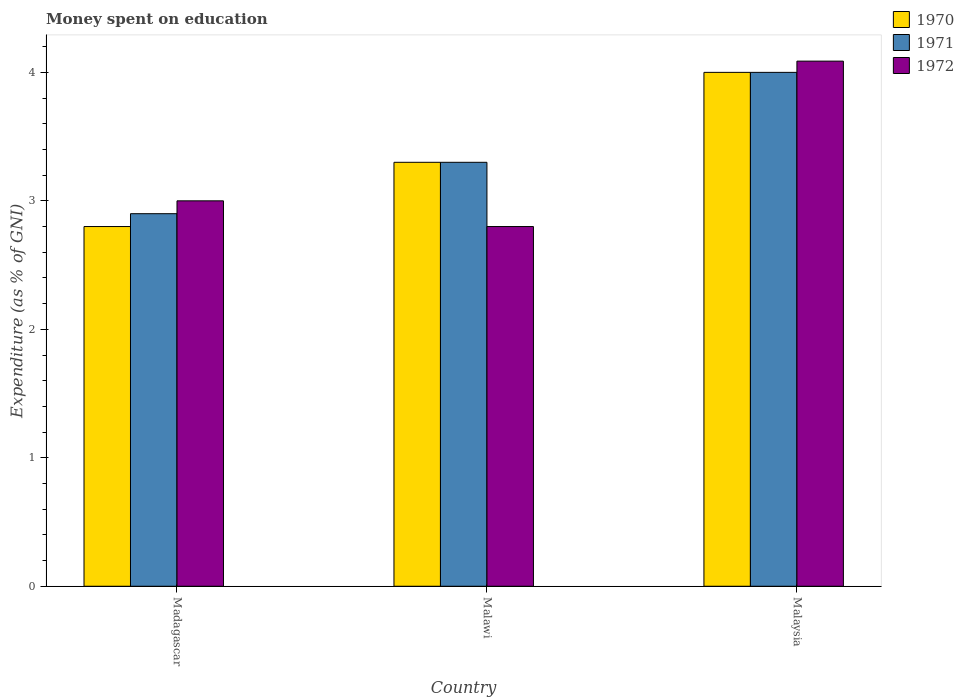How many different coloured bars are there?
Keep it short and to the point. 3. Are the number of bars per tick equal to the number of legend labels?
Offer a very short reply. Yes. How many bars are there on the 2nd tick from the left?
Ensure brevity in your answer.  3. What is the label of the 3rd group of bars from the left?
Provide a succinct answer. Malaysia. What is the amount of money spent on education in 1970 in Malaysia?
Provide a succinct answer. 4. Across all countries, what is the maximum amount of money spent on education in 1970?
Your answer should be compact. 4. In which country was the amount of money spent on education in 1972 maximum?
Your answer should be very brief. Malaysia. In which country was the amount of money spent on education in 1971 minimum?
Give a very brief answer. Madagascar. What is the total amount of money spent on education in 1971 in the graph?
Offer a terse response. 10.2. What is the difference between the amount of money spent on education in 1972 in Malawi and that in Malaysia?
Your answer should be very brief. -1.29. What is the difference between the amount of money spent on education in 1970 in Malawi and the amount of money spent on education in 1971 in Madagascar?
Provide a short and direct response. 0.4. What is the difference between the amount of money spent on education of/in 1972 and amount of money spent on education of/in 1971 in Madagascar?
Provide a short and direct response. 0.1. What is the ratio of the amount of money spent on education in 1971 in Malawi to that in Malaysia?
Give a very brief answer. 0.82. Is the amount of money spent on education in 1972 in Madagascar less than that in Malawi?
Your response must be concise. No. What is the difference between the highest and the second highest amount of money spent on education in 1972?
Ensure brevity in your answer.  -0.2. What is the difference between the highest and the lowest amount of money spent on education in 1970?
Your answer should be compact. 1.2. Is the sum of the amount of money spent on education in 1971 in Malawi and Malaysia greater than the maximum amount of money spent on education in 1970 across all countries?
Keep it short and to the point. Yes. What does the 1st bar from the left in Malawi represents?
Provide a short and direct response. 1970. What does the 2nd bar from the right in Madagascar represents?
Your answer should be very brief. 1971. Is it the case that in every country, the sum of the amount of money spent on education in 1971 and amount of money spent on education in 1972 is greater than the amount of money spent on education in 1970?
Provide a short and direct response. Yes. How many bars are there?
Provide a short and direct response. 9. How many countries are there in the graph?
Give a very brief answer. 3. Does the graph contain any zero values?
Your response must be concise. No. What is the title of the graph?
Your answer should be very brief. Money spent on education. Does "1975" appear as one of the legend labels in the graph?
Make the answer very short. No. What is the label or title of the Y-axis?
Your answer should be compact. Expenditure (as % of GNI). What is the Expenditure (as % of GNI) of 1972 in Madagascar?
Provide a succinct answer. 3. What is the Expenditure (as % of GNI) in 1972 in Malawi?
Your answer should be compact. 2.8. What is the Expenditure (as % of GNI) in 1972 in Malaysia?
Your answer should be very brief. 4.09. Across all countries, what is the maximum Expenditure (as % of GNI) of 1972?
Keep it short and to the point. 4.09. What is the total Expenditure (as % of GNI) of 1970 in the graph?
Your answer should be compact. 10.1. What is the total Expenditure (as % of GNI) of 1972 in the graph?
Offer a very short reply. 9.89. What is the difference between the Expenditure (as % of GNI) of 1972 in Madagascar and that in Malawi?
Provide a short and direct response. 0.2. What is the difference between the Expenditure (as % of GNI) in 1970 in Madagascar and that in Malaysia?
Provide a succinct answer. -1.2. What is the difference between the Expenditure (as % of GNI) in 1971 in Madagascar and that in Malaysia?
Offer a terse response. -1.1. What is the difference between the Expenditure (as % of GNI) of 1972 in Madagascar and that in Malaysia?
Offer a terse response. -1.09. What is the difference between the Expenditure (as % of GNI) in 1972 in Malawi and that in Malaysia?
Give a very brief answer. -1.29. What is the difference between the Expenditure (as % of GNI) in 1970 in Madagascar and the Expenditure (as % of GNI) in 1971 in Malawi?
Give a very brief answer. -0.5. What is the difference between the Expenditure (as % of GNI) in 1970 in Madagascar and the Expenditure (as % of GNI) in 1972 in Malawi?
Your answer should be very brief. 0. What is the difference between the Expenditure (as % of GNI) of 1970 in Madagascar and the Expenditure (as % of GNI) of 1971 in Malaysia?
Provide a short and direct response. -1.2. What is the difference between the Expenditure (as % of GNI) of 1970 in Madagascar and the Expenditure (as % of GNI) of 1972 in Malaysia?
Your answer should be very brief. -1.29. What is the difference between the Expenditure (as % of GNI) of 1971 in Madagascar and the Expenditure (as % of GNI) of 1972 in Malaysia?
Make the answer very short. -1.19. What is the difference between the Expenditure (as % of GNI) of 1970 in Malawi and the Expenditure (as % of GNI) of 1972 in Malaysia?
Give a very brief answer. -0.79. What is the difference between the Expenditure (as % of GNI) in 1971 in Malawi and the Expenditure (as % of GNI) in 1972 in Malaysia?
Your answer should be very brief. -0.79. What is the average Expenditure (as % of GNI) in 1970 per country?
Your response must be concise. 3.37. What is the average Expenditure (as % of GNI) of 1972 per country?
Make the answer very short. 3.3. What is the difference between the Expenditure (as % of GNI) in 1970 and Expenditure (as % of GNI) in 1971 in Madagascar?
Your answer should be compact. -0.1. What is the difference between the Expenditure (as % of GNI) of 1970 and Expenditure (as % of GNI) of 1972 in Malawi?
Make the answer very short. 0.5. What is the difference between the Expenditure (as % of GNI) of 1971 and Expenditure (as % of GNI) of 1972 in Malawi?
Offer a terse response. 0.5. What is the difference between the Expenditure (as % of GNI) of 1970 and Expenditure (as % of GNI) of 1972 in Malaysia?
Ensure brevity in your answer.  -0.09. What is the difference between the Expenditure (as % of GNI) of 1971 and Expenditure (as % of GNI) of 1972 in Malaysia?
Give a very brief answer. -0.09. What is the ratio of the Expenditure (as % of GNI) of 1970 in Madagascar to that in Malawi?
Your response must be concise. 0.85. What is the ratio of the Expenditure (as % of GNI) of 1971 in Madagascar to that in Malawi?
Keep it short and to the point. 0.88. What is the ratio of the Expenditure (as % of GNI) of 1972 in Madagascar to that in Malawi?
Your response must be concise. 1.07. What is the ratio of the Expenditure (as % of GNI) of 1970 in Madagascar to that in Malaysia?
Ensure brevity in your answer.  0.7. What is the ratio of the Expenditure (as % of GNI) in 1971 in Madagascar to that in Malaysia?
Provide a succinct answer. 0.72. What is the ratio of the Expenditure (as % of GNI) of 1972 in Madagascar to that in Malaysia?
Offer a very short reply. 0.73. What is the ratio of the Expenditure (as % of GNI) in 1970 in Malawi to that in Malaysia?
Keep it short and to the point. 0.82. What is the ratio of the Expenditure (as % of GNI) of 1971 in Malawi to that in Malaysia?
Your response must be concise. 0.82. What is the ratio of the Expenditure (as % of GNI) of 1972 in Malawi to that in Malaysia?
Give a very brief answer. 0.69. What is the difference between the highest and the second highest Expenditure (as % of GNI) in 1971?
Offer a very short reply. 0.7. What is the difference between the highest and the second highest Expenditure (as % of GNI) of 1972?
Your answer should be compact. 1.09. What is the difference between the highest and the lowest Expenditure (as % of GNI) in 1971?
Give a very brief answer. 1.1. What is the difference between the highest and the lowest Expenditure (as % of GNI) in 1972?
Your response must be concise. 1.29. 